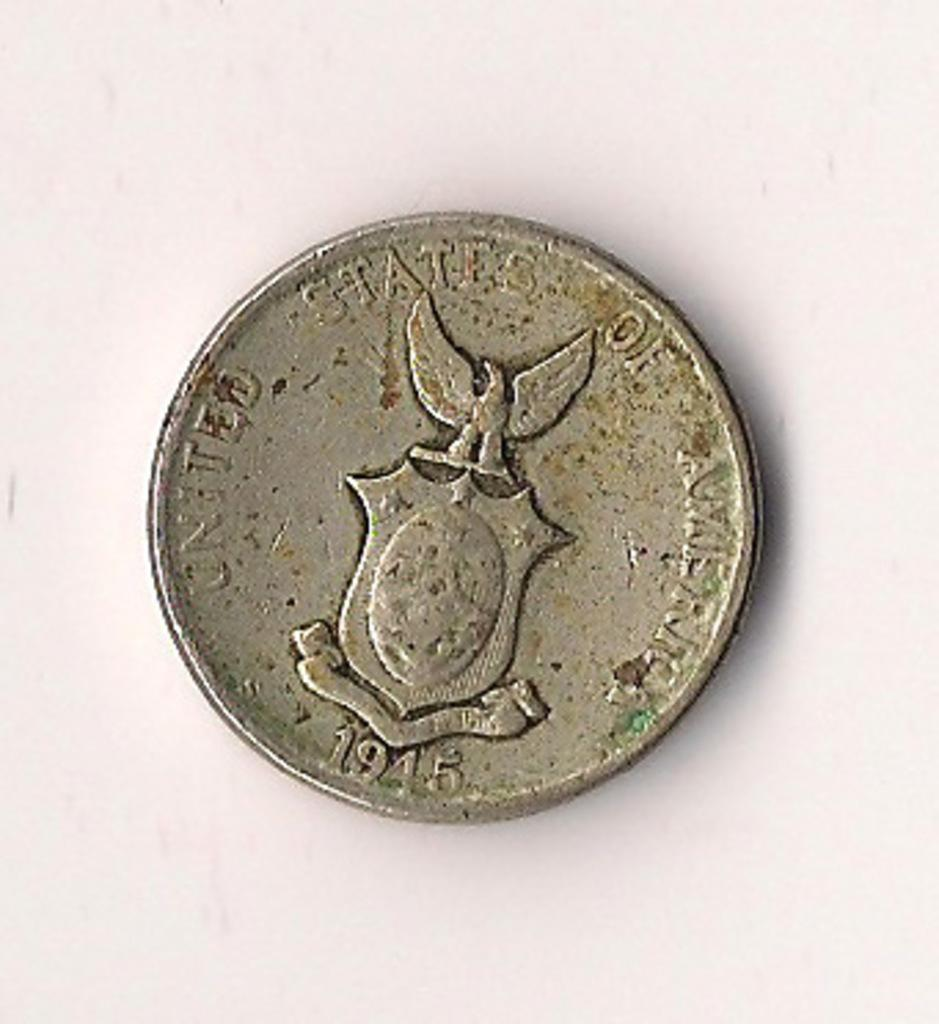<image>
Summarize the visual content of the image. Weird coin with a symbol of an eagle and the year 1945. 